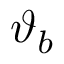<formula> <loc_0><loc_0><loc_500><loc_500>\vartheta _ { b }</formula> 